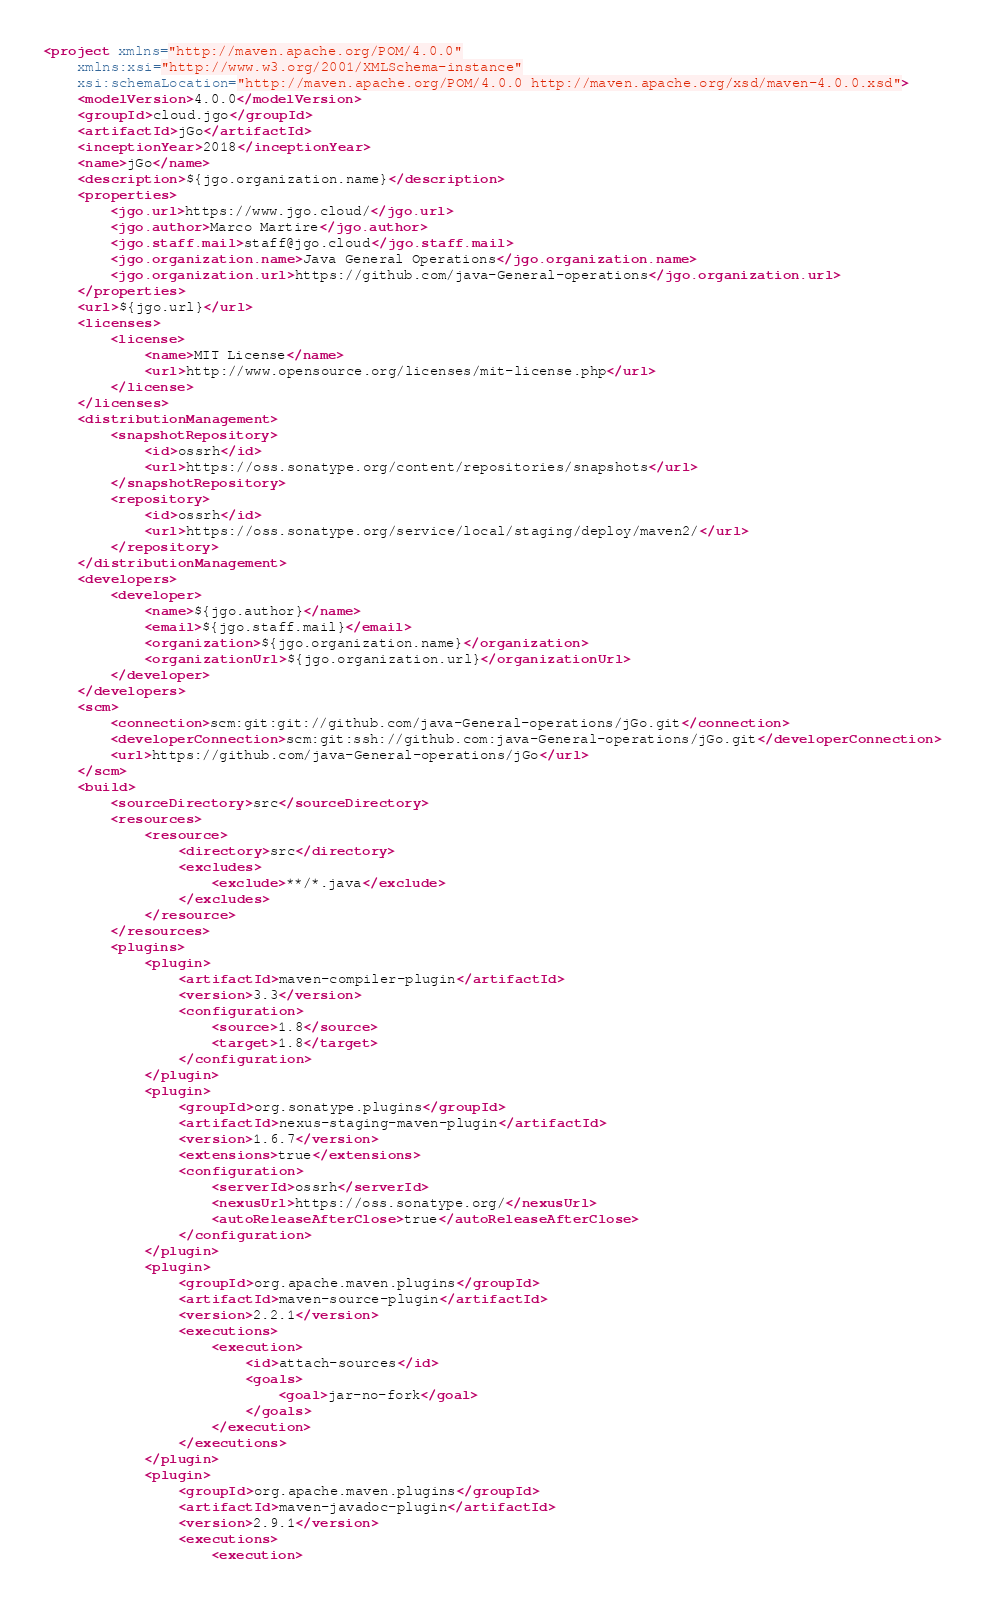Convert code to text. <code><loc_0><loc_0><loc_500><loc_500><_XML_><project xmlns="http://maven.apache.org/POM/4.0.0"
	xmlns:xsi="http://www.w3.org/2001/XMLSchema-instance"
	xsi:schemaLocation="http://maven.apache.org/POM/4.0.0 http://maven.apache.org/xsd/maven-4.0.0.xsd">
	<modelVersion>4.0.0</modelVersion>
	<groupId>cloud.jgo</groupId>
	<artifactId>jGo</artifactId>
	<inceptionYear>2018</inceptionYear>
	<name>jGo</name>
	<description>${jgo.organization.name}</description>
	<properties>
		<jgo.url>https://www.jgo.cloud/</jgo.url>
		<jgo.author>Marco Martire</jgo.author>
		<jgo.staff.mail>staff@jgo.cloud</jgo.staff.mail>
		<jgo.organization.name>Java General Operations</jgo.organization.name>
		<jgo.organization.url>https://github.com/java-General-operations</jgo.organization.url>
	</properties>
	<url>${jgo.url}</url>
	<licenses>
		<license>
			<name>MIT License</name>
			<url>http://www.opensource.org/licenses/mit-license.php</url>
		</license>
	</licenses>
	<distributionManagement>
		<snapshotRepository>
			<id>ossrh</id>
			<url>https://oss.sonatype.org/content/repositories/snapshots</url>
		</snapshotRepository>
		<repository>
			<id>ossrh</id>
			<url>https://oss.sonatype.org/service/local/staging/deploy/maven2/</url>
		</repository>
	</distributionManagement>
	<developers>
		<developer>
			<name>${jgo.author}</name>
			<email>${jgo.staff.mail}</email>
			<organization>${jgo.organization.name}</organization>
			<organizationUrl>${jgo.organization.url}</organizationUrl>
		</developer>
	</developers>
	<scm>
		<connection>scm:git:git://github.com/java-General-operations/jGo.git</connection>
		<developerConnection>scm:git:ssh://github.com:java-General-operations/jGo.git</developerConnection>
		<url>https://github.com/java-General-operations/jGo</url>
	</scm>
	<build>
		<sourceDirectory>src</sourceDirectory>
		<resources>
			<resource>
				<directory>src</directory>
				<excludes>
					<exclude>**/*.java</exclude>
				</excludes>
			</resource>
		</resources>
		<plugins>
			<plugin>
				<artifactId>maven-compiler-plugin</artifactId>
				<version>3.3</version>
				<configuration>
					<source>1.8</source>
					<target>1.8</target>
				</configuration>
			</plugin>
			<plugin>
				<groupId>org.sonatype.plugins</groupId>
				<artifactId>nexus-staging-maven-plugin</artifactId>
				<version>1.6.7</version>
				<extensions>true</extensions>
				<configuration>
					<serverId>ossrh</serverId>
					<nexusUrl>https://oss.sonatype.org/</nexusUrl>
					<autoReleaseAfterClose>true</autoReleaseAfterClose>
				</configuration>
			</plugin>
			<plugin>
				<groupId>org.apache.maven.plugins</groupId>
				<artifactId>maven-source-plugin</artifactId>
				<version>2.2.1</version>
				<executions>
					<execution>
						<id>attach-sources</id>
						<goals>
							<goal>jar-no-fork</goal>
						</goals>
					</execution>
				</executions>
			</plugin>
			<plugin>
				<groupId>org.apache.maven.plugins</groupId>
				<artifactId>maven-javadoc-plugin</artifactId>
				<version>2.9.1</version>
				<executions>
					<execution></code> 